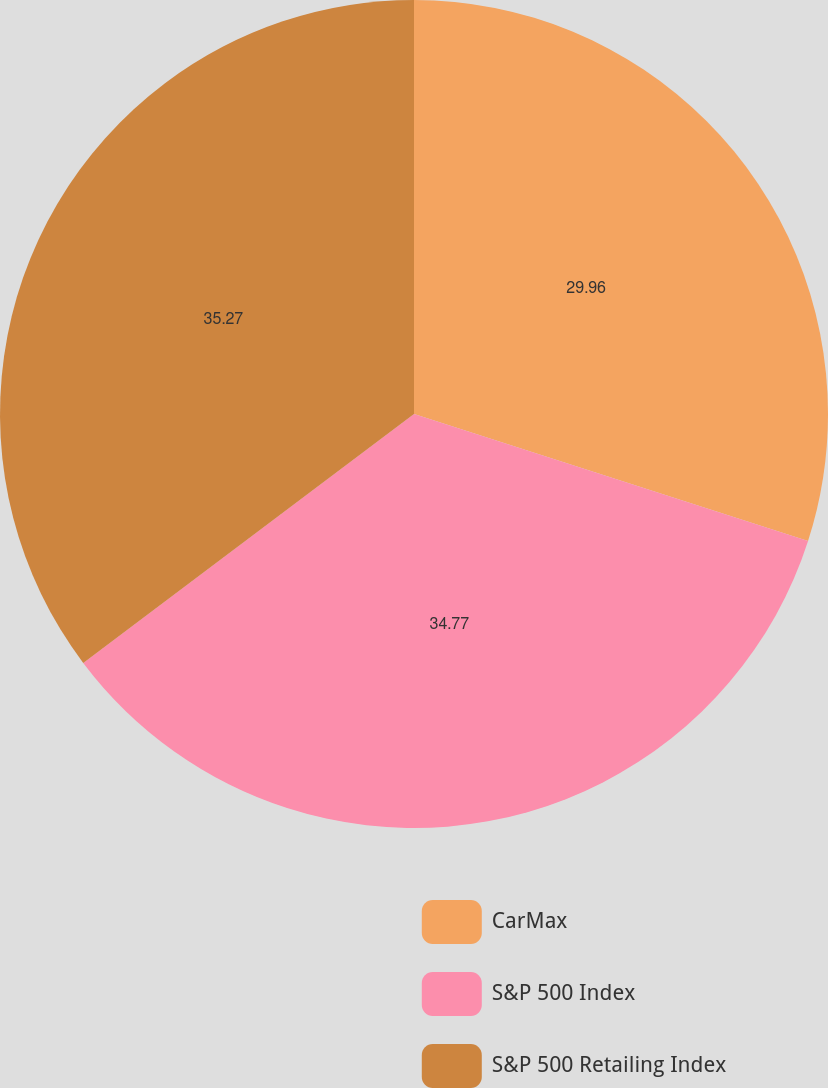Convert chart to OTSL. <chart><loc_0><loc_0><loc_500><loc_500><pie_chart><fcel>CarMax<fcel>S&P 500 Index<fcel>S&P 500 Retailing Index<nl><fcel>29.96%<fcel>34.77%<fcel>35.27%<nl></chart> 